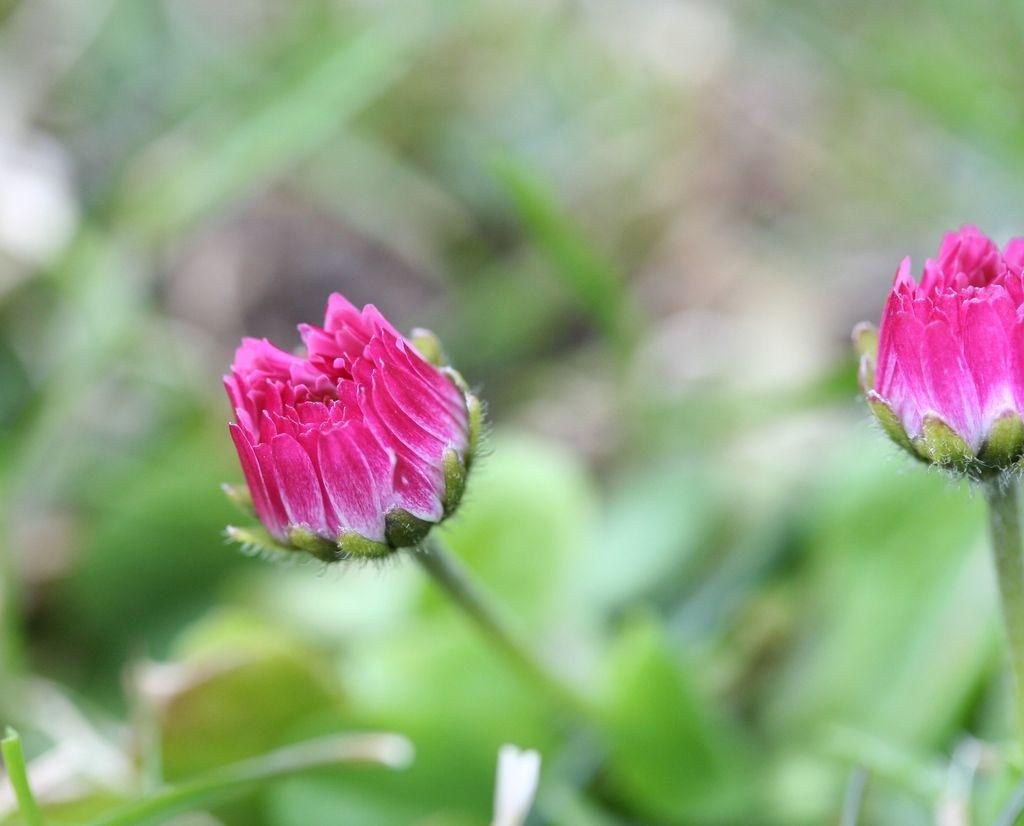How many flowers are present in the image? There are two flowers in the image. What color are the flowers? The flowers are pink in color. What can be seen below the flowers in the image? There is greenery below the flowers. Is there an arch made of flowers in the image? No, there is no arch made of flowers in the image. 